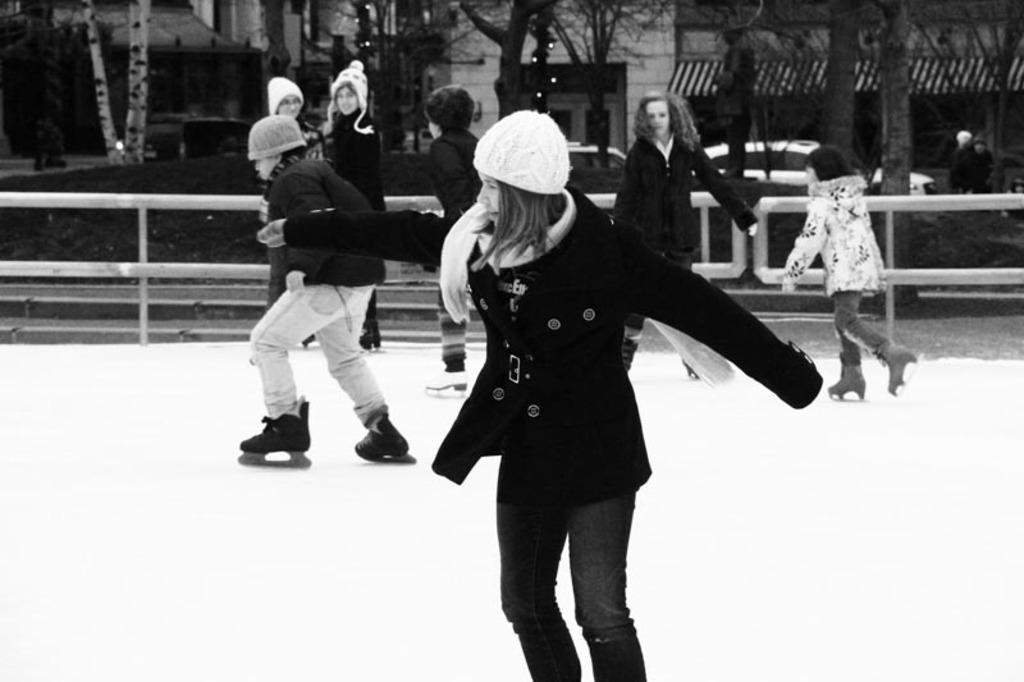How many people are in the image? There is a group of people in the image, but the exact number cannot be determined from the provided facts. What is the surface the people are standing on? The people are standing on snow. What type of footwear is one person wearing? One person is wearing skating shoes. What can be seen in the background of the image? There is a fence, buildings, trees, and vehicles visible in the background of the image. What type of frame is visible in the image? There is no mention of a frame in the provided facts, so it cannot be seen in the image. 